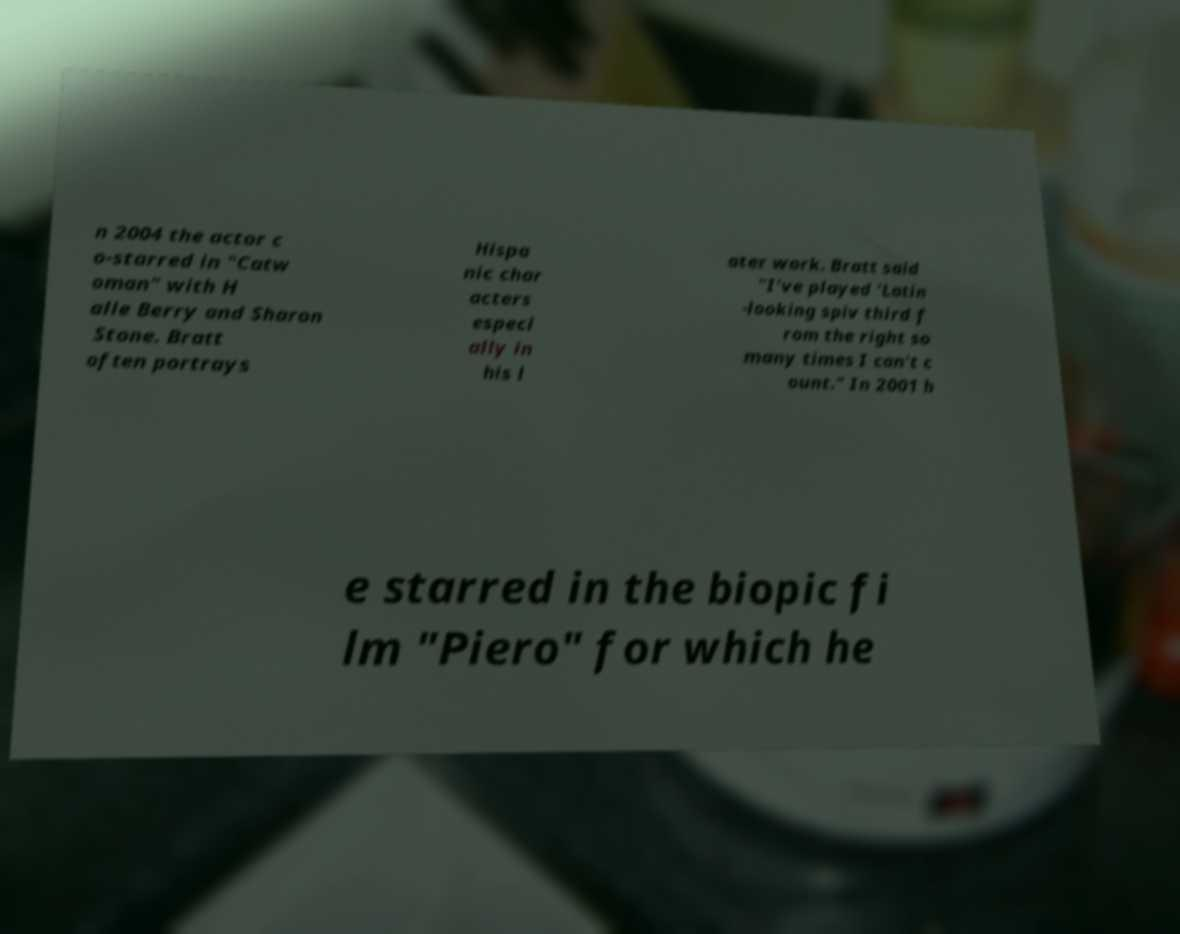Please read and relay the text visible in this image. What does it say? n 2004 the actor c o-starred in "Catw oman" with H alle Berry and Sharon Stone. Bratt often portrays Hispa nic char acters especi ally in his l ater work. Bratt said "I've played 'Latin -looking spiv third f rom the right so many times I can't c ount." In 2001 h e starred in the biopic fi lm "Piero" for which he 